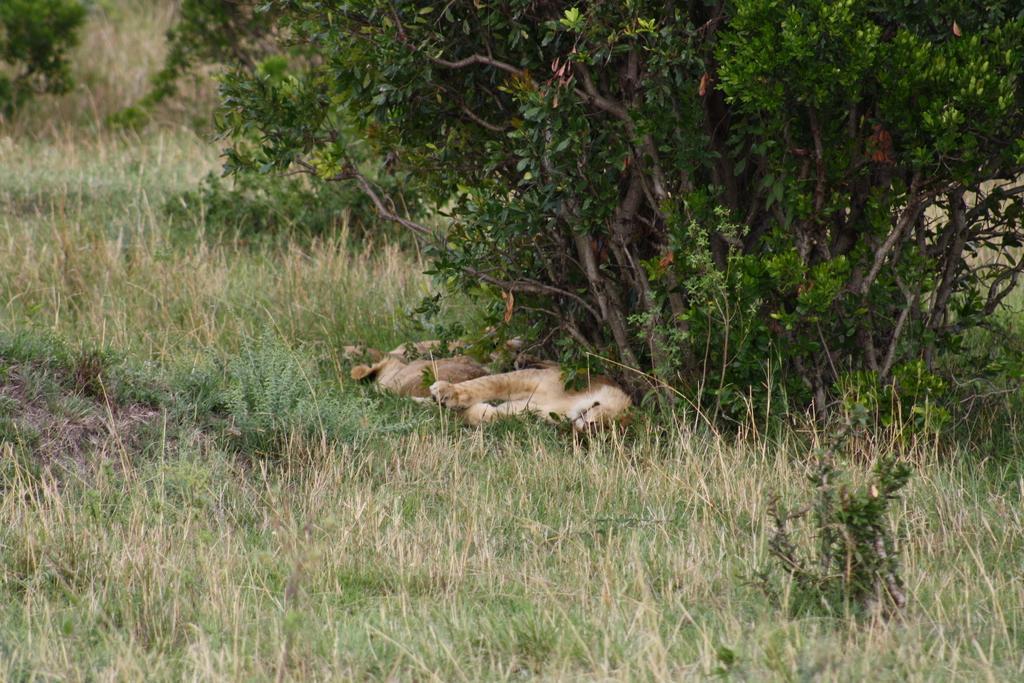Describe this image in one or two sentences. In this image I can see some grass which is green and brown in color and I can see two animals which are cream and brown in color are laying on the ground. I can see few trees which are green and brown in color. 